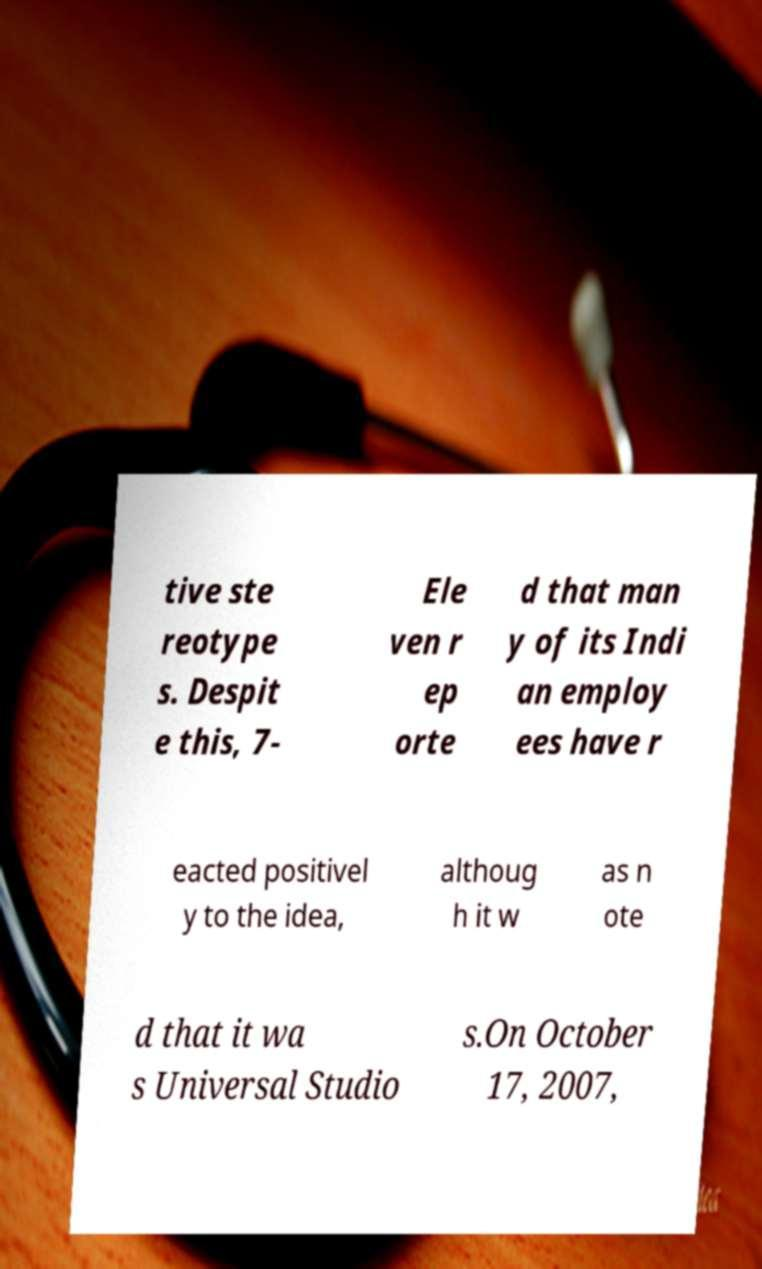Can you accurately transcribe the text from the provided image for me? tive ste reotype s. Despit e this, 7- Ele ven r ep orte d that man y of its Indi an employ ees have r eacted positivel y to the idea, althoug h it w as n ote d that it wa s Universal Studio s.On October 17, 2007, 